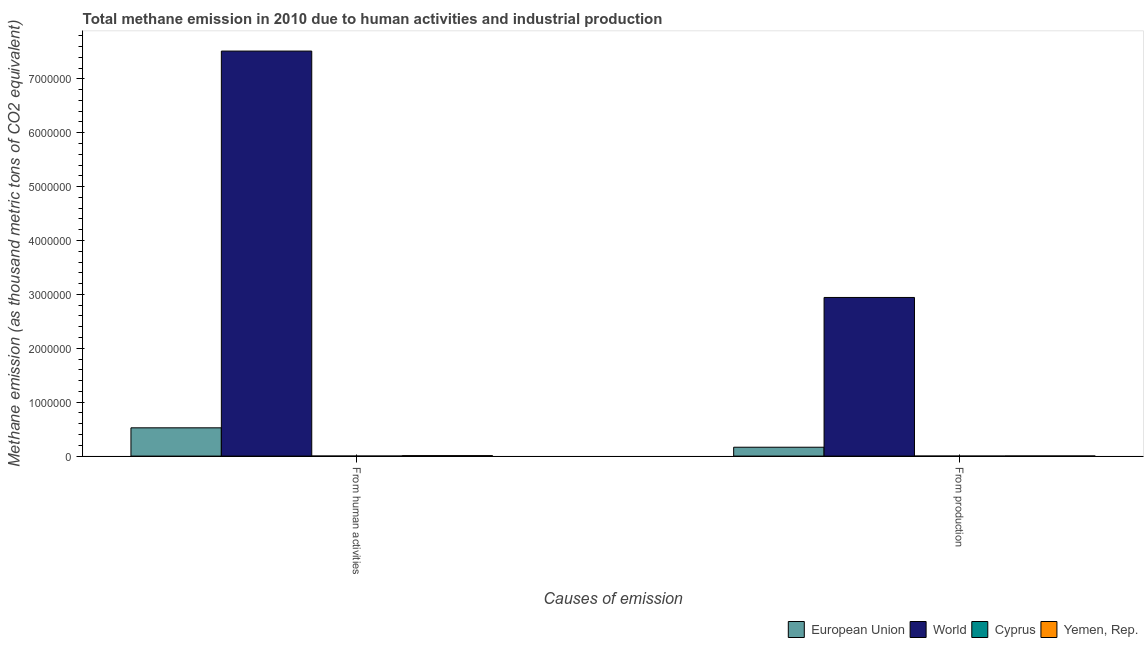How many groups of bars are there?
Make the answer very short. 2. Are the number of bars per tick equal to the number of legend labels?
Give a very brief answer. Yes. What is the label of the 1st group of bars from the left?
Your response must be concise. From human activities. Across all countries, what is the maximum amount of emissions from human activities?
Offer a terse response. 7.52e+06. Across all countries, what is the minimum amount of emissions from human activities?
Make the answer very short. 621.4. In which country was the amount of emissions generated from industries maximum?
Ensure brevity in your answer.  World. In which country was the amount of emissions generated from industries minimum?
Offer a very short reply. Cyprus. What is the total amount of emissions generated from industries in the graph?
Your answer should be compact. 3.11e+06. What is the difference between the amount of emissions from human activities in Yemen, Rep. and that in Cyprus?
Keep it short and to the point. 8143.3. What is the difference between the amount of emissions from human activities in Cyprus and the amount of emissions generated from industries in Yemen, Rep.?
Offer a terse response. -1766.9. What is the average amount of emissions from human activities per country?
Your answer should be very brief. 2.01e+06. What is the difference between the amount of emissions generated from industries and amount of emissions from human activities in European Union?
Offer a very short reply. -3.60e+05. In how many countries, is the amount of emissions generated from industries greater than 7000000 thousand metric tons?
Your answer should be very brief. 0. What is the ratio of the amount of emissions generated from industries in World to that in European Union?
Provide a short and direct response. 17.86. What does the 4th bar from the left in From production represents?
Keep it short and to the point. Yemen, Rep. What does the 1st bar from the right in From human activities represents?
Give a very brief answer. Yemen, Rep. How many countries are there in the graph?
Make the answer very short. 4. Are the values on the major ticks of Y-axis written in scientific E-notation?
Your response must be concise. No. Does the graph contain any zero values?
Provide a succinct answer. No. Where does the legend appear in the graph?
Give a very brief answer. Bottom right. How many legend labels are there?
Keep it short and to the point. 4. How are the legend labels stacked?
Provide a short and direct response. Horizontal. What is the title of the graph?
Your answer should be very brief. Total methane emission in 2010 due to human activities and industrial production. What is the label or title of the X-axis?
Offer a very short reply. Causes of emission. What is the label or title of the Y-axis?
Your answer should be compact. Methane emission (as thousand metric tons of CO2 equivalent). What is the Methane emission (as thousand metric tons of CO2 equivalent) in European Union in From human activities?
Your answer should be very brief. 5.25e+05. What is the Methane emission (as thousand metric tons of CO2 equivalent) in World in From human activities?
Your answer should be very brief. 7.52e+06. What is the Methane emission (as thousand metric tons of CO2 equivalent) in Cyprus in From human activities?
Give a very brief answer. 621.4. What is the Methane emission (as thousand metric tons of CO2 equivalent) of Yemen, Rep. in From human activities?
Provide a succinct answer. 8764.7. What is the Methane emission (as thousand metric tons of CO2 equivalent) of European Union in From production?
Offer a terse response. 1.65e+05. What is the Methane emission (as thousand metric tons of CO2 equivalent) in World in From production?
Make the answer very short. 2.94e+06. What is the Methane emission (as thousand metric tons of CO2 equivalent) in Yemen, Rep. in From production?
Keep it short and to the point. 2388.3. Across all Causes of emission, what is the maximum Methane emission (as thousand metric tons of CO2 equivalent) in European Union?
Provide a succinct answer. 5.25e+05. Across all Causes of emission, what is the maximum Methane emission (as thousand metric tons of CO2 equivalent) in World?
Your answer should be very brief. 7.52e+06. Across all Causes of emission, what is the maximum Methane emission (as thousand metric tons of CO2 equivalent) in Cyprus?
Your answer should be compact. 621.4. Across all Causes of emission, what is the maximum Methane emission (as thousand metric tons of CO2 equivalent) in Yemen, Rep.?
Your response must be concise. 8764.7. Across all Causes of emission, what is the minimum Methane emission (as thousand metric tons of CO2 equivalent) in European Union?
Your answer should be compact. 1.65e+05. Across all Causes of emission, what is the minimum Methane emission (as thousand metric tons of CO2 equivalent) in World?
Make the answer very short. 2.94e+06. Across all Causes of emission, what is the minimum Methane emission (as thousand metric tons of CO2 equivalent) of Cyprus?
Your response must be concise. 13.3. Across all Causes of emission, what is the minimum Methane emission (as thousand metric tons of CO2 equivalent) of Yemen, Rep.?
Offer a terse response. 2388.3. What is the total Methane emission (as thousand metric tons of CO2 equivalent) in European Union in the graph?
Make the answer very short. 6.90e+05. What is the total Methane emission (as thousand metric tons of CO2 equivalent) of World in the graph?
Provide a short and direct response. 1.05e+07. What is the total Methane emission (as thousand metric tons of CO2 equivalent) of Cyprus in the graph?
Ensure brevity in your answer.  634.7. What is the total Methane emission (as thousand metric tons of CO2 equivalent) in Yemen, Rep. in the graph?
Provide a succinct answer. 1.12e+04. What is the difference between the Methane emission (as thousand metric tons of CO2 equivalent) in European Union in From human activities and that in From production?
Give a very brief answer. 3.60e+05. What is the difference between the Methane emission (as thousand metric tons of CO2 equivalent) of World in From human activities and that in From production?
Provide a succinct answer. 4.57e+06. What is the difference between the Methane emission (as thousand metric tons of CO2 equivalent) of Cyprus in From human activities and that in From production?
Provide a short and direct response. 608.1. What is the difference between the Methane emission (as thousand metric tons of CO2 equivalent) of Yemen, Rep. in From human activities and that in From production?
Ensure brevity in your answer.  6376.4. What is the difference between the Methane emission (as thousand metric tons of CO2 equivalent) of European Union in From human activities and the Methane emission (as thousand metric tons of CO2 equivalent) of World in From production?
Ensure brevity in your answer.  -2.42e+06. What is the difference between the Methane emission (as thousand metric tons of CO2 equivalent) in European Union in From human activities and the Methane emission (as thousand metric tons of CO2 equivalent) in Cyprus in From production?
Provide a succinct answer. 5.25e+05. What is the difference between the Methane emission (as thousand metric tons of CO2 equivalent) in European Union in From human activities and the Methane emission (as thousand metric tons of CO2 equivalent) in Yemen, Rep. in From production?
Your answer should be compact. 5.22e+05. What is the difference between the Methane emission (as thousand metric tons of CO2 equivalent) in World in From human activities and the Methane emission (as thousand metric tons of CO2 equivalent) in Cyprus in From production?
Make the answer very short. 7.52e+06. What is the difference between the Methane emission (as thousand metric tons of CO2 equivalent) in World in From human activities and the Methane emission (as thousand metric tons of CO2 equivalent) in Yemen, Rep. in From production?
Your answer should be very brief. 7.51e+06. What is the difference between the Methane emission (as thousand metric tons of CO2 equivalent) of Cyprus in From human activities and the Methane emission (as thousand metric tons of CO2 equivalent) of Yemen, Rep. in From production?
Your response must be concise. -1766.9. What is the average Methane emission (as thousand metric tons of CO2 equivalent) of European Union per Causes of emission?
Ensure brevity in your answer.  3.45e+05. What is the average Methane emission (as thousand metric tons of CO2 equivalent) of World per Causes of emission?
Keep it short and to the point. 5.23e+06. What is the average Methane emission (as thousand metric tons of CO2 equivalent) in Cyprus per Causes of emission?
Provide a short and direct response. 317.35. What is the average Methane emission (as thousand metric tons of CO2 equivalent) of Yemen, Rep. per Causes of emission?
Offer a very short reply. 5576.5. What is the difference between the Methane emission (as thousand metric tons of CO2 equivalent) in European Union and Methane emission (as thousand metric tons of CO2 equivalent) in World in From human activities?
Keep it short and to the point. -6.99e+06. What is the difference between the Methane emission (as thousand metric tons of CO2 equivalent) of European Union and Methane emission (as thousand metric tons of CO2 equivalent) of Cyprus in From human activities?
Keep it short and to the point. 5.24e+05. What is the difference between the Methane emission (as thousand metric tons of CO2 equivalent) of European Union and Methane emission (as thousand metric tons of CO2 equivalent) of Yemen, Rep. in From human activities?
Offer a terse response. 5.16e+05. What is the difference between the Methane emission (as thousand metric tons of CO2 equivalent) in World and Methane emission (as thousand metric tons of CO2 equivalent) in Cyprus in From human activities?
Make the answer very short. 7.51e+06. What is the difference between the Methane emission (as thousand metric tons of CO2 equivalent) of World and Methane emission (as thousand metric tons of CO2 equivalent) of Yemen, Rep. in From human activities?
Make the answer very short. 7.51e+06. What is the difference between the Methane emission (as thousand metric tons of CO2 equivalent) in Cyprus and Methane emission (as thousand metric tons of CO2 equivalent) in Yemen, Rep. in From human activities?
Your response must be concise. -8143.3. What is the difference between the Methane emission (as thousand metric tons of CO2 equivalent) of European Union and Methane emission (as thousand metric tons of CO2 equivalent) of World in From production?
Your response must be concise. -2.78e+06. What is the difference between the Methane emission (as thousand metric tons of CO2 equivalent) in European Union and Methane emission (as thousand metric tons of CO2 equivalent) in Cyprus in From production?
Your answer should be very brief. 1.65e+05. What is the difference between the Methane emission (as thousand metric tons of CO2 equivalent) in European Union and Methane emission (as thousand metric tons of CO2 equivalent) in Yemen, Rep. in From production?
Your answer should be very brief. 1.62e+05. What is the difference between the Methane emission (as thousand metric tons of CO2 equivalent) of World and Methane emission (as thousand metric tons of CO2 equivalent) of Cyprus in From production?
Provide a succinct answer. 2.94e+06. What is the difference between the Methane emission (as thousand metric tons of CO2 equivalent) in World and Methane emission (as thousand metric tons of CO2 equivalent) in Yemen, Rep. in From production?
Ensure brevity in your answer.  2.94e+06. What is the difference between the Methane emission (as thousand metric tons of CO2 equivalent) of Cyprus and Methane emission (as thousand metric tons of CO2 equivalent) of Yemen, Rep. in From production?
Provide a succinct answer. -2375. What is the ratio of the Methane emission (as thousand metric tons of CO2 equivalent) of European Union in From human activities to that in From production?
Your response must be concise. 3.18. What is the ratio of the Methane emission (as thousand metric tons of CO2 equivalent) of World in From human activities to that in From production?
Keep it short and to the point. 2.55. What is the ratio of the Methane emission (as thousand metric tons of CO2 equivalent) in Cyprus in From human activities to that in From production?
Give a very brief answer. 46.72. What is the ratio of the Methane emission (as thousand metric tons of CO2 equivalent) of Yemen, Rep. in From human activities to that in From production?
Make the answer very short. 3.67. What is the difference between the highest and the second highest Methane emission (as thousand metric tons of CO2 equivalent) in European Union?
Your answer should be very brief. 3.60e+05. What is the difference between the highest and the second highest Methane emission (as thousand metric tons of CO2 equivalent) in World?
Ensure brevity in your answer.  4.57e+06. What is the difference between the highest and the second highest Methane emission (as thousand metric tons of CO2 equivalent) in Cyprus?
Keep it short and to the point. 608.1. What is the difference between the highest and the second highest Methane emission (as thousand metric tons of CO2 equivalent) of Yemen, Rep.?
Provide a succinct answer. 6376.4. What is the difference between the highest and the lowest Methane emission (as thousand metric tons of CO2 equivalent) in European Union?
Offer a very short reply. 3.60e+05. What is the difference between the highest and the lowest Methane emission (as thousand metric tons of CO2 equivalent) in World?
Your response must be concise. 4.57e+06. What is the difference between the highest and the lowest Methane emission (as thousand metric tons of CO2 equivalent) of Cyprus?
Ensure brevity in your answer.  608.1. What is the difference between the highest and the lowest Methane emission (as thousand metric tons of CO2 equivalent) in Yemen, Rep.?
Offer a terse response. 6376.4. 